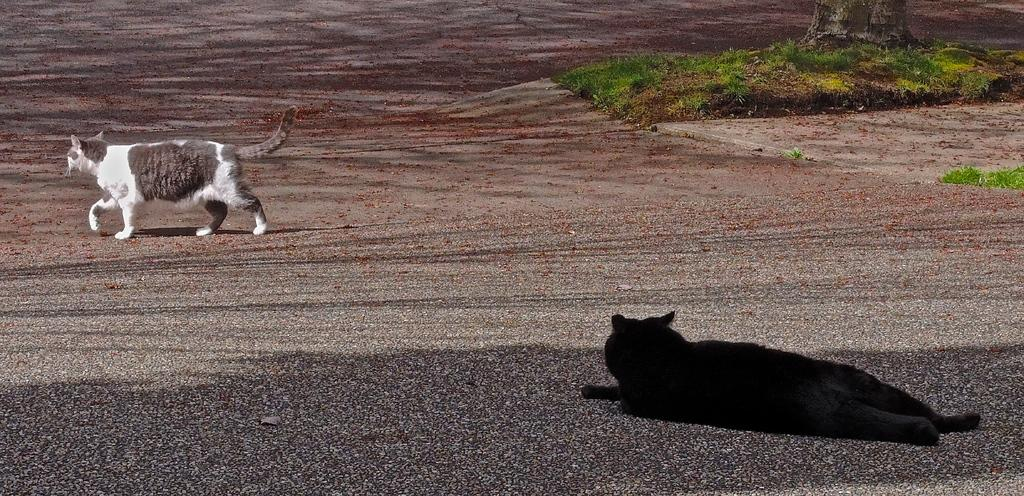What type of animal is laying on the path in the image? There is a black animal laying on the path in the image. What other animal can be seen on the path? There is a cat walking on the path in the image. What can be seen in the background of the image? People, grass, and a tree trunk are visible in the background of the image. What type of cellar can be seen in the image? There is no cellar present in the image. Is the image taken during the night or day? The image does not provide information about the time of day, so it cannot be determined if it was taken during the night or day. 